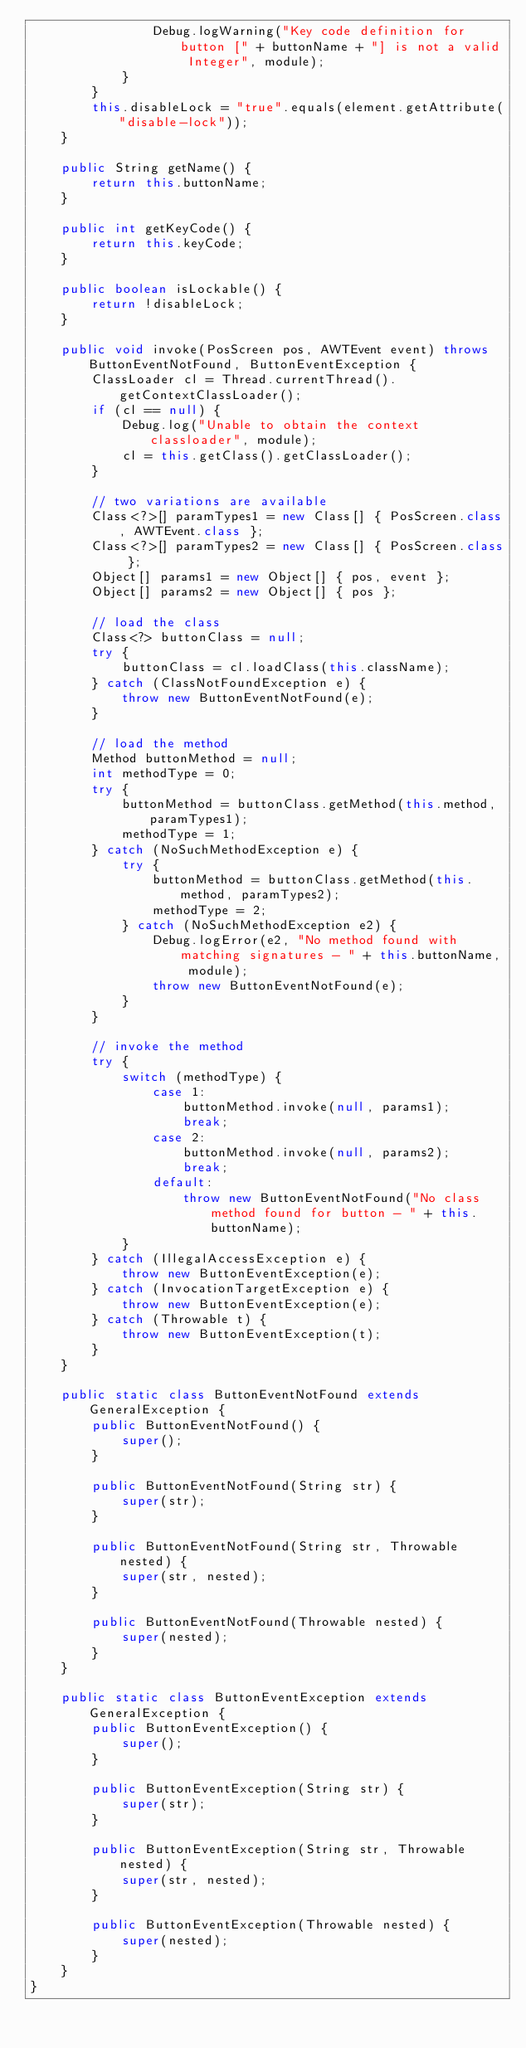Convert code to text. <code><loc_0><loc_0><loc_500><loc_500><_Java_>                Debug.logWarning("Key code definition for button [" + buttonName + "] is not a valid Integer", module);
            }
        }
        this.disableLock = "true".equals(element.getAttribute("disable-lock"));
    }

    public String getName() {
        return this.buttonName;
    }

    public int getKeyCode() {
        return this.keyCode;
    }

    public boolean isLockable() {
        return !disableLock;
    }

    public void invoke(PosScreen pos, AWTEvent event) throws ButtonEventNotFound, ButtonEventException {
        ClassLoader cl = Thread.currentThread().getContextClassLoader();
        if (cl == null) {
            Debug.log("Unable to obtain the context classloader", module);
            cl = this.getClass().getClassLoader();
        }

        // two variations are available
        Class<?>[] paramTypes1 = new Class[] { PosScreen.class, AWTEvent.class };
        Class<?>[] paramTypes2 = new Class[] { PosScreen.class };
        Object[] params1 = new Object[] { pos, event };
        Object[] params2 = new Object[] { pos };

        // load the class
        Class<?> buttonClass = null;
        try {
            buttonClass = cl.loadClass(this.className);
        } catch (ClassNotFoundException e) {
            throw new ButtonEventNotFound(e);
        }

        // load the method
        Method buttonMethod = null;
        int methodType = 0;
        try {
            buttonMethod = buttonClass.getMethod(this.method, paramTypes1);
            methodType = 1;
        } catch (NoSuchMethodException e) {
            try {
                buttonMethod = buttonClass.getMethod(this.method, paramTypes2);
                methodType = 2;
            } catch (NoSuchMethodException e2) {
                Debug.logError(e2, "No method found with matching signatures - " + this.buttonName, module);
                throw new ButtonEventNotFound(e);
            }
        }

        // invoke the method
        try {
            switch (methodType) {
                case 1:
                    buttonMethod.invoke(null, params1);
                    break;
                case 2:
                    buttonMethod.invoke(null, params2);
                    break;
                default:
                    throw new ButtonEventNotFound("No class method found for button - " + this.buttonName);
            }
        } catch (IllegalAccessException e) {
            throw new ButtonEventException(e);
        } catch (InvocationTargetException e) {
            throw new ButtonEventException(e);
        } catch (Throwable t) {
            throw new ButtonEventException(t);
        }
    }

    public static class ButtonEventNotFound extends GeneralException {
        public ButtonEventNotFound() {
            super();
        }

        public ButtonEventNotFound(String str) {
            super(str);
        }

        public ButtonEventNotFound(String str, Throwable nested) {
            super(str, nested);
        }

        public ButtonEventNotFound(Throwable nested) {
            super(nested);
        }
    }

    public static class ButtonEventException extends GeneralException {
        public ButtonEventException() {
            super();
        }

        public ButtonEventException(String str) {
            super(str);
        }

        public ButtonEventException(String str, Throwable nested) {
            super(str, nested);
        }

        public ButtonEventException(Throwable nested) {
            super(nested);
        }
    }
}
</code> 